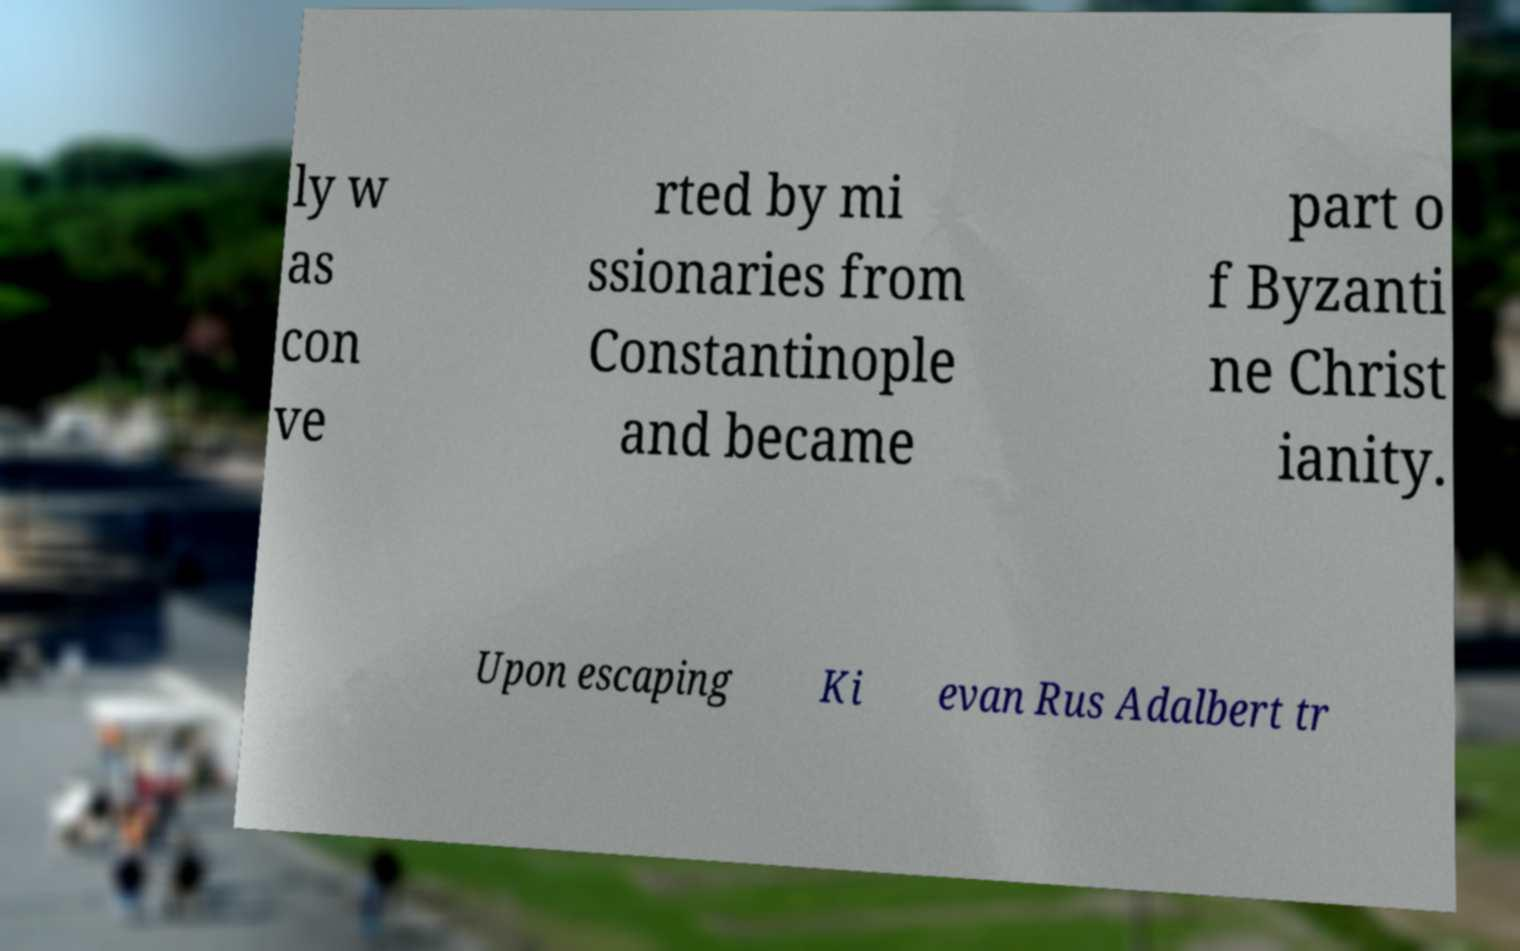Could you assist in decoding the text presented in this image and type it out clearly? ly w as con ve rted by mi ssionaries from Constantinople and became part o f Byzanti ne Christ ianity. Upon escaping Ki evan Rus Adalbert tr 